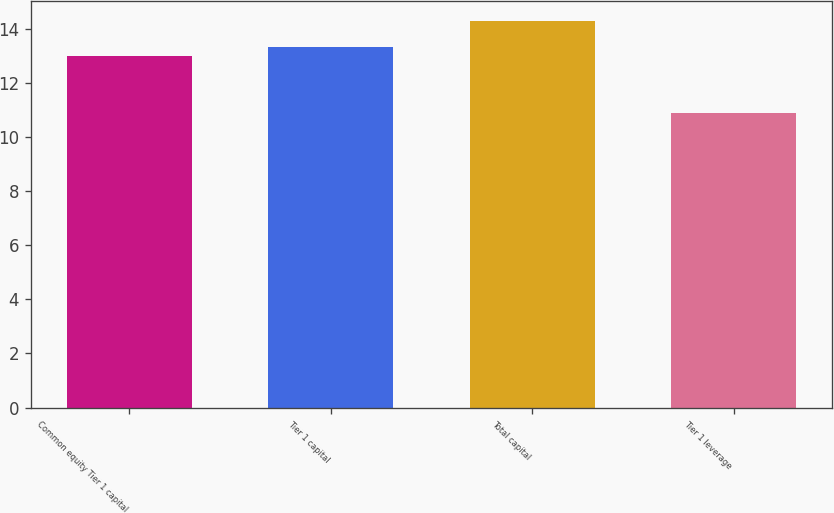<chart> <loc_0><loc_0><loc_500><loc_500><bar_chart><fcel>Common equity Tier 1 capital<fcel>Tier 1 capital<fcel>Total capital<fcel>Tier 1 leverage<nl><fcel>13<fcel>13.34<fcel>14.3<fcel>10.9<nl></chart> 